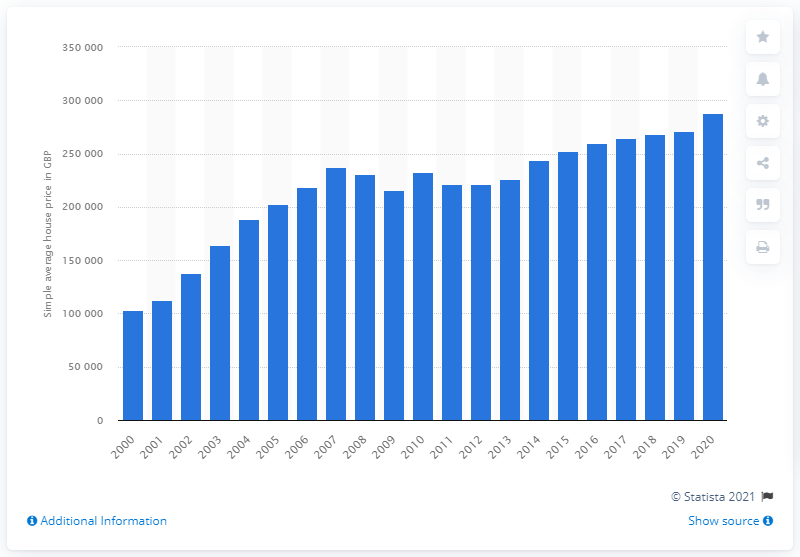Give some essential details in this illustration. The value of the simple average house price for bungalow dwellings in the United Kingdom in 2020 was 288,000. The smallest average house price for bungalow dwellings since 2010 was 221,000. 